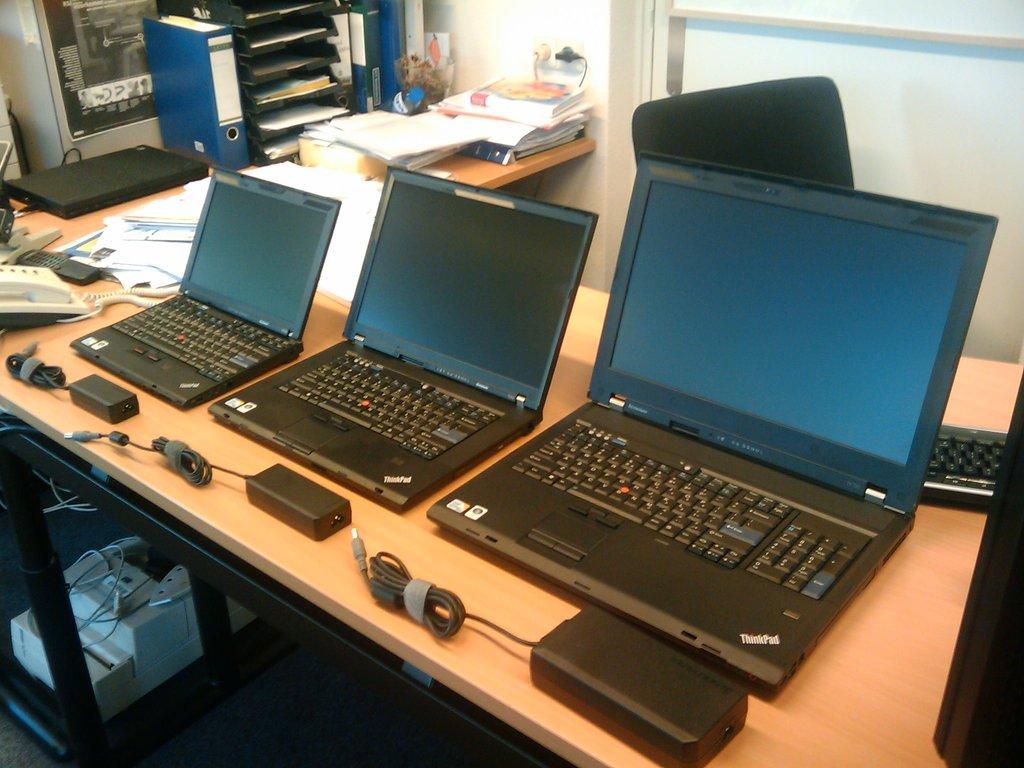What is the model line of these computers?
Your response must be concise. Unanswerable. 